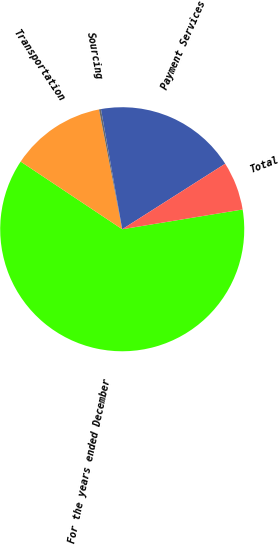Convert chart. <chart><loc_0><loc_0><loc_500><loc_500><pie_chart><fcel>For the years ended December<fcel>Transportation<fcel>Sourcing<fcel>Payment Services<fcel>Total<nl><fcel>61.95%<fcel>12.6%<fcel>0.26%<fcel>18.77%<fcel>6.43%<nl></chart> 